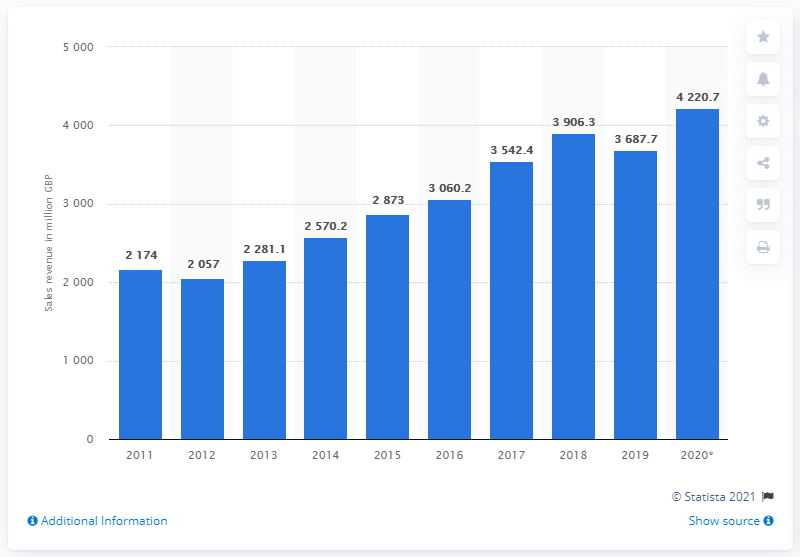Outline some significant characteristics in this image. In 2020, British consumers spent approximately 4,220.7 pounds on video games. 